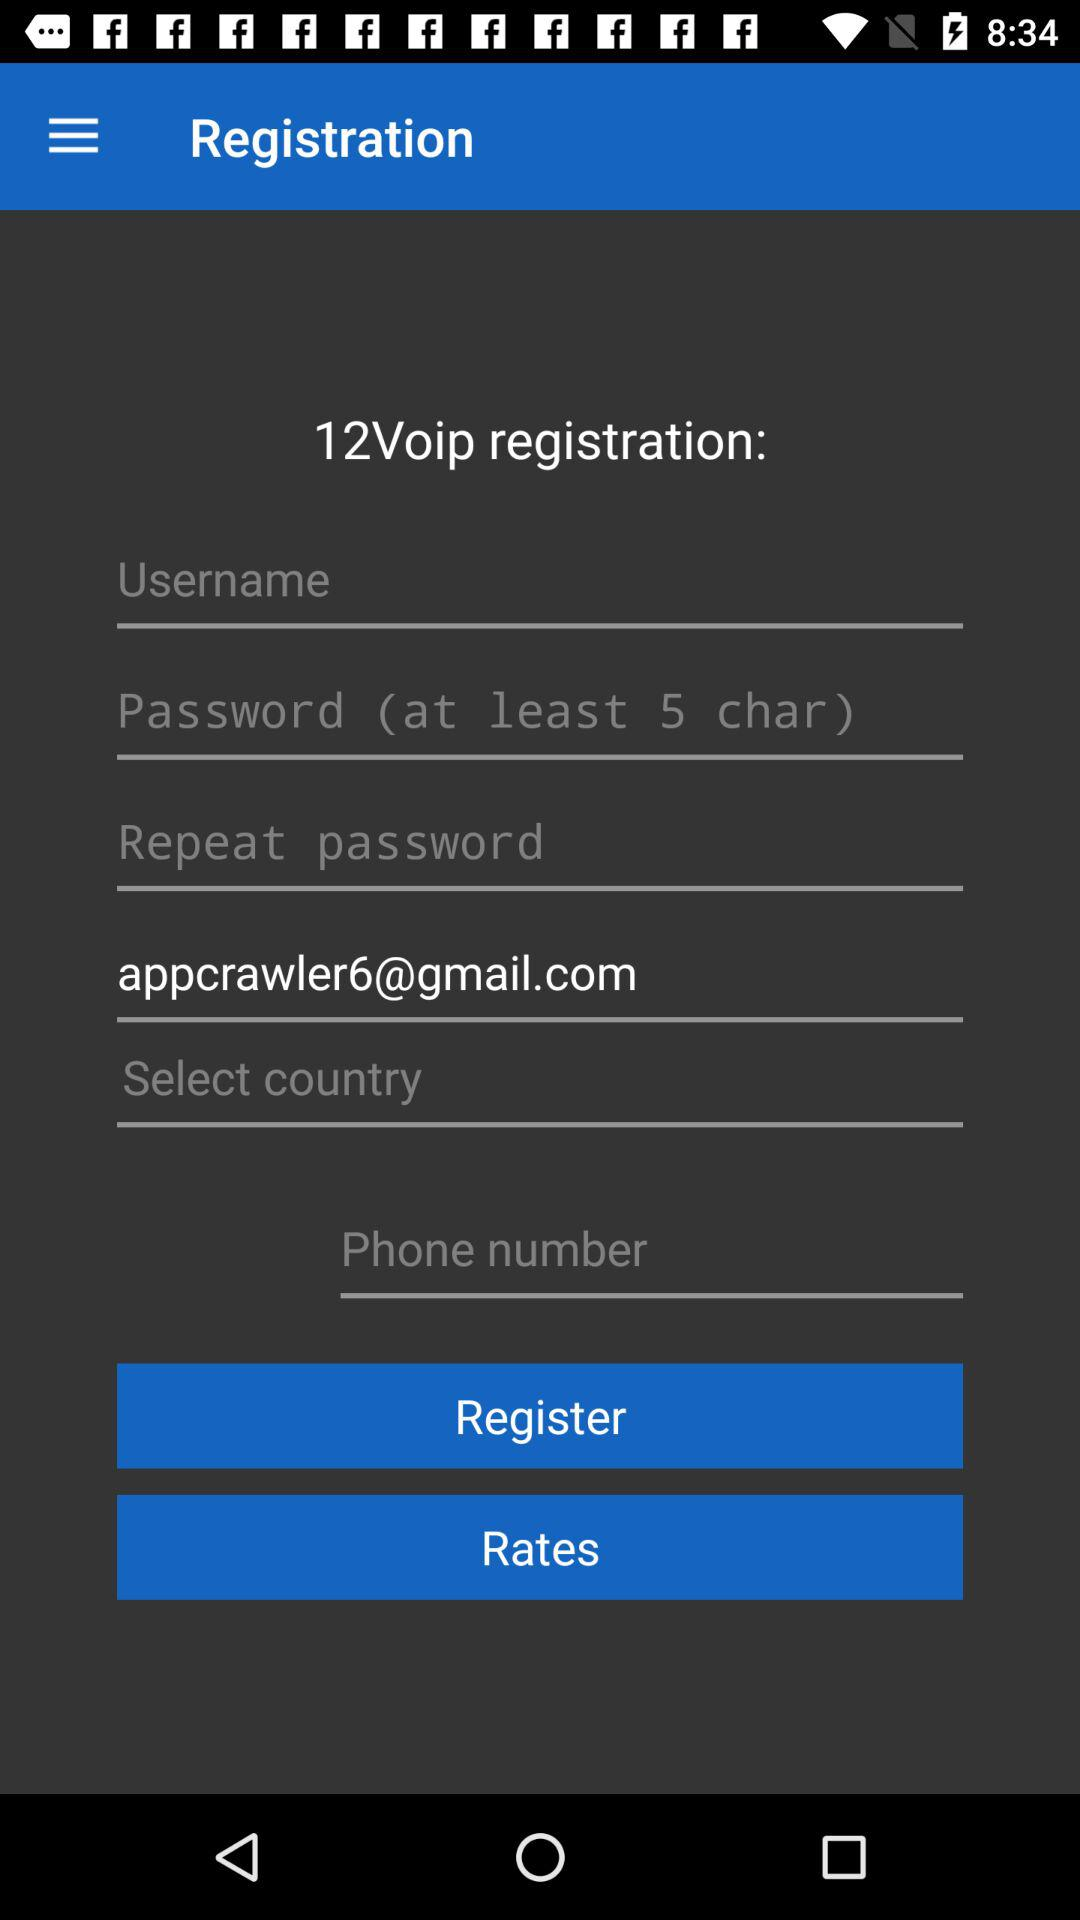What is the application name? The application name is 12Voip. 